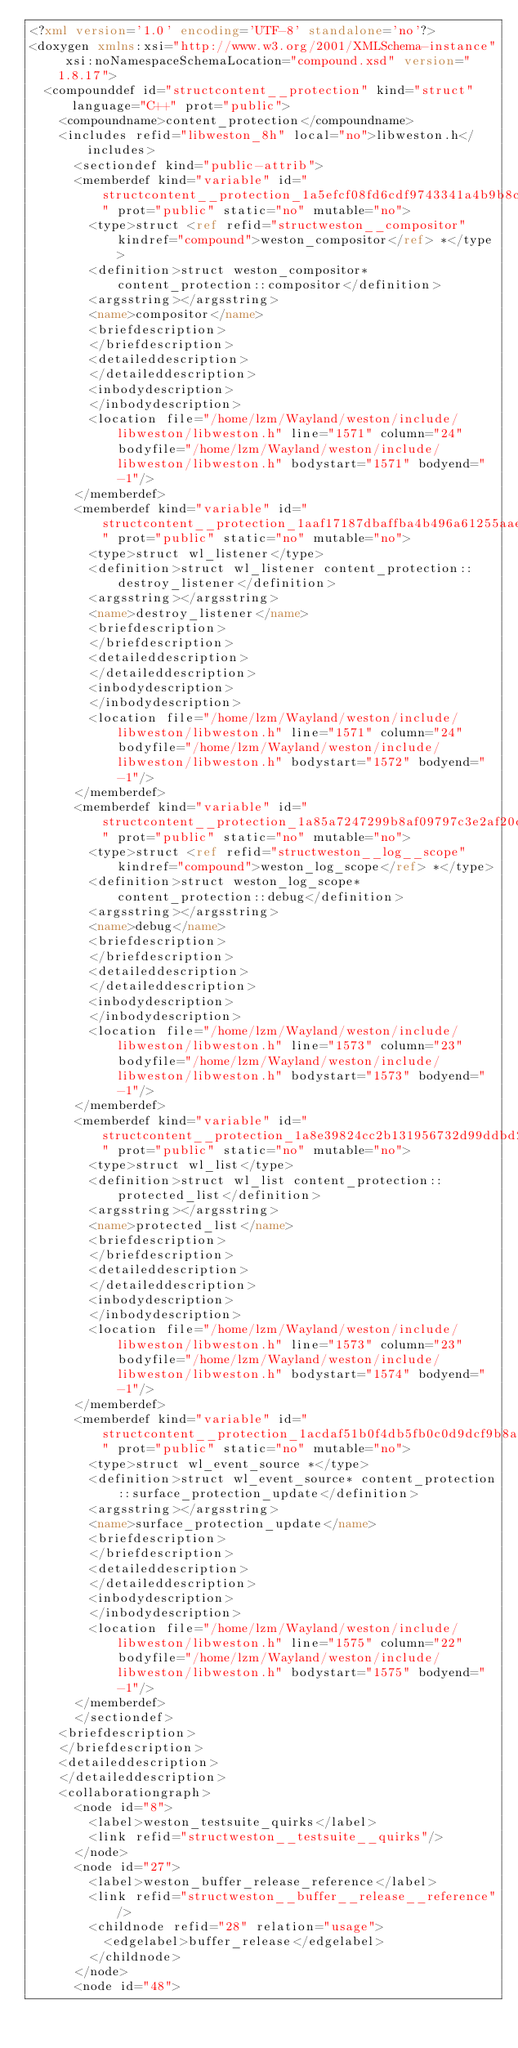<code> <loc_0><loc_0><loc_500><loc_500><_XML_><?xml version='1.0' encoding='UTF-8' standalone='no'?>
<doxygen xmlns:xsi="http://www.w3.org/2001/XMLSchema-instance" xsi:noNamespaceSchemaLocation="compound.xsd" version="1.8.17">
  <compounddef id="structcontent__protection" kind="struct" language="C++" prot="public">
    <compoundname>content_protection</compoundname>
    <includes refid="libweston_8h" local="no">libweston.h</includes>
      <sectiondef kind="public-attrib">
      <memberdef kind="variable" id="structcontent__protection_1a5efcf08fd6cdf9743341a4b9b8ceeff8" prot="public" static="no" mutable="no">
        <type>struct <ref refid="structweston__compositor" kindref="compound">weston_compositor</ref> *</type>
        <definition>struct weston_compositor* content_protection::compositor</definition>
        <argsstring></argsstring>
        <name>compositor</name>
        <briefdescription>
        </briefdescription>
        <detaileddescription>
        </detaileddescription>
        <inbodydescription>
        </inbodydescription>
        <location file="/home/lzm/Wayland/weston/include/libweston/libweston.h" line="1571" column="24" bodyfile="/home/lzm/Wayland/weston/include/libweston/libweston.h" bodystart="1571" bodyend="-1"/>
      </memberdef>
      <memberdef kind="variable" id="structcontent__protection_1aaf17187dbaffba4b496a61255aaed109" prot="public" static="no" mutable="no">
        <type>struct wl_listener</type>
        <definition>struct wl_listener content_protection::destroy_listener</definition>
        <argsstring></argsstring>
        <name>destroy_listener</name>
        <briefdescription>
        </briefdescription>
        <detaileddescription>
        </detaileddescription>
        <inbodydescription>
        </inbodydescription>
        <location file="/home/lzm/Wayland/weston/include/libweston/libweston.h" line="1571" column="24" bodyfile="/home/lzm/Wayland/weston/include/libweston/libweston.h" bodystart="1572" bodyend="-1"/>
      </memberdef>
      <memberdef kind="variable" id="structcontent__protection_1a85a7247299b8af09797c3e2af20cd92e" prot="public" static="no" mutable="no">
        <type>struct <ref refid="structweston__log__scope" kindref="compound">weston_log_scope</ref> *</type>
        <definition>struct weston_log_scope* content_protection::debug</definition>
        <argsstring></argsstring>
        <name>debug</name>
        <briefdescription>
        </briefdescription>
        <detaileddescription>
        </detaileddescription>
        <inbodydescription>
        </inbodydescription>
        <location file="/home/lzm/Wayland/weston/include/libweston/libweston.h" line="1573" column="23" bodyfile="/home/lzm/Wayland/weston/include/libweston/libweston.h" bodystart="1573" bodyend="-1"/>
      </memberdef>
      <memberdef kind="variable" id="structcontent__protection_1a8e39824cc2b131956732d99ddbd27e4a" prot="public" static="no" mutable="no">
        <type>struct wl_list</type>
        <definition>struct wl_list content_protection::protected_list</definition>
        <argsstring></argsstring>
        <name>protected_list</name>
        <briefdescription>
        </briefdescription>
        <detaileddescription>
        </detaileddescription>
        <inbodydescription>
        </inbodydescription>
        <location file="/home/lzm/Wayland/weston/include/libweston/libweston.h" line="1573" column="23" bodyfile="/home/lzm/Wayland/weston/include/libweston/libweston.h" bodystart="1574" bodyend="-1"/>
      </memberdef>
      <memberdef kind="variable" id="structcontent__protection_1acdaf51b0f4db5fb0c0d9dcf9b8ab7cfe" prot="public" static="no" mutable="no">
        <type>struct wl_event_source *</type>
        <definition>struct wl_event_source* content_protection::surface_protection_update</definition>
        <argsstring></argsstring>
        <name>surface_protection_update</name>
        <briefdescription>
        </briefdescription>
        <detaileddescription>
        </detaileddescription>
        <inbodydescription>
        </inbodydescription>
        <location file="/home/lzm/Wayland/weston/include/libweston/libweston.h" line="1575" column="22" bodyfile="/home/lzm/Wayland/weston/include/libweston/libweston.h" bodystart="1575" bodyend="-1"/>
      </memberdef>
      </sectiondef>
    <briefdescription>
    </briefdescription>
    <detaileddescription>
    </detaileddescription>
    <collaborationgraph>
      <node id="8">
        <label>weston_testsuite_quirks</label>
        <link refid="structweston__testsuite__quirks"/>
      </node>
      <node id="27">
        <label>weston_buffer_release_reference</label>
        <link refid="structweston__buffer__release__reference"/>
        <childnode refid="28" relation="usage">
          <edgelabel>buffer_release</edgelabel>
        </childnode>
      </node>
      <node id="48"></code> 